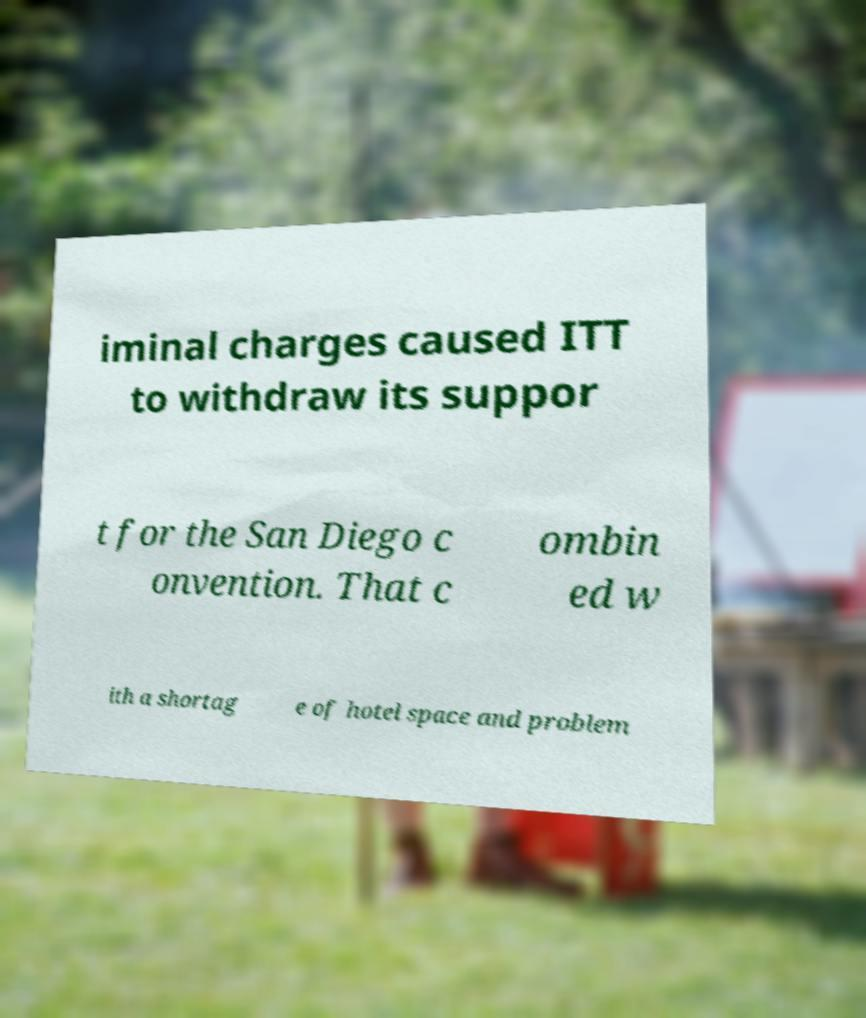For documentation purposes, I need the text within this image transcribed. Could you provide that? iminal charges caused ITT to withdraw its suppor t for the San Diego c onvention. That c ombin ed w ith a shortag e of hotel space and problem 